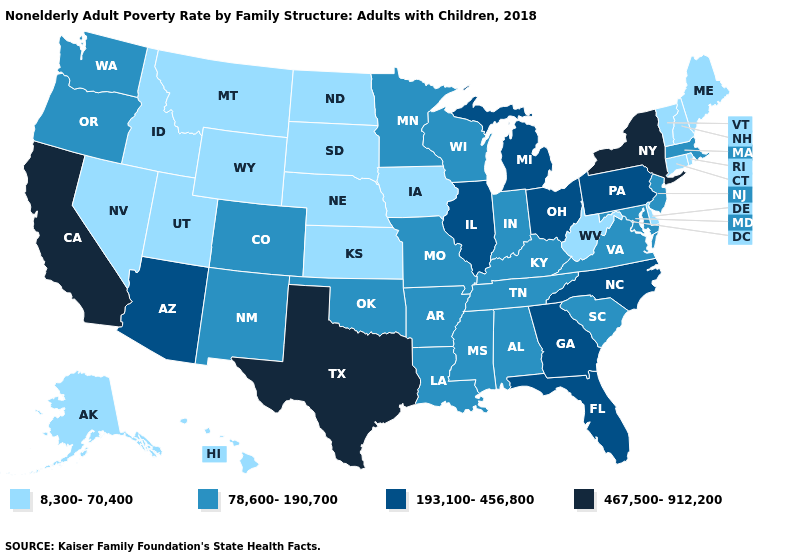Among the states that border New York , which have the highest value?
Concise answer only. Pennsylvania. Name the states that have a value in the range 8,300-70,400?
Write a very short answer. Alaska, Connecticut, Delaware, Hawaii, Idaho, Iowa, Kansas, Maine, Montana, Nebraska, Nevada, New Hampshire, North Dakota, Rhode Island, South Dakota, Utah, Vermont, West Virginia, Wyoming. Does the map have missing data?
Keep it brief. No. Does Indiana have a higher value than Missouri?
Concise answer only. No. Does Illinois have a higher value than Montana?
Be succinct. Yes. What is the highest value in the USA?
Quick response, please. 467,500-912,200. Does Rhode Island have the lowest value in the USA?
Keep it brief. Yes. What is the value of West Virginia?
Concise answer only. 8,300-70,400. Which states have the lowest value in the South?
Write a very short answer. Delaware, West Virginia. Does the map have missing data?
Give a very brief answer. No. Does the first symbol in the legend represent the smallest category?
Short answer required. Yes. What is the lowest value in the MidWest?
Answer briefly. 8,300-70,400. What is the value of Maine?
Short answer required. 8,300-70,400. Among the states that border Arizona , which have the lowest value?
Keep it brief. Nevada, Utah. Does Texas have the highest value in the USA?
Keep it brief. Yes. 